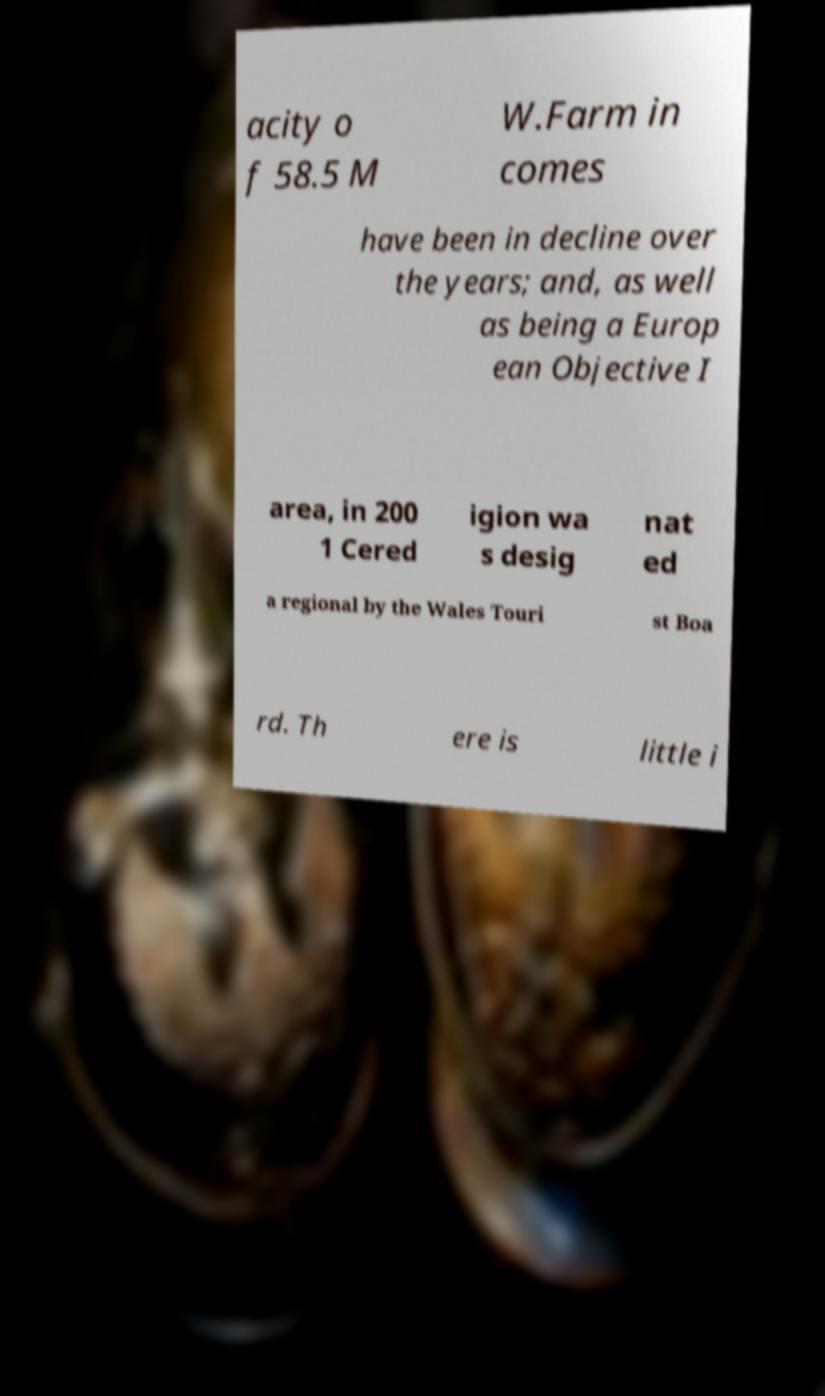Could you assist in decoding the text presented in this image and type it out clearly? acity o f 58.5 M W.Farm in comes have been in decline over the years; and, as well as being a Europ ean Objective I area, in 200 1 Cered igion wa s desig nat ed a regional by the Wales Touri st Boa rd. Th ere is little i 